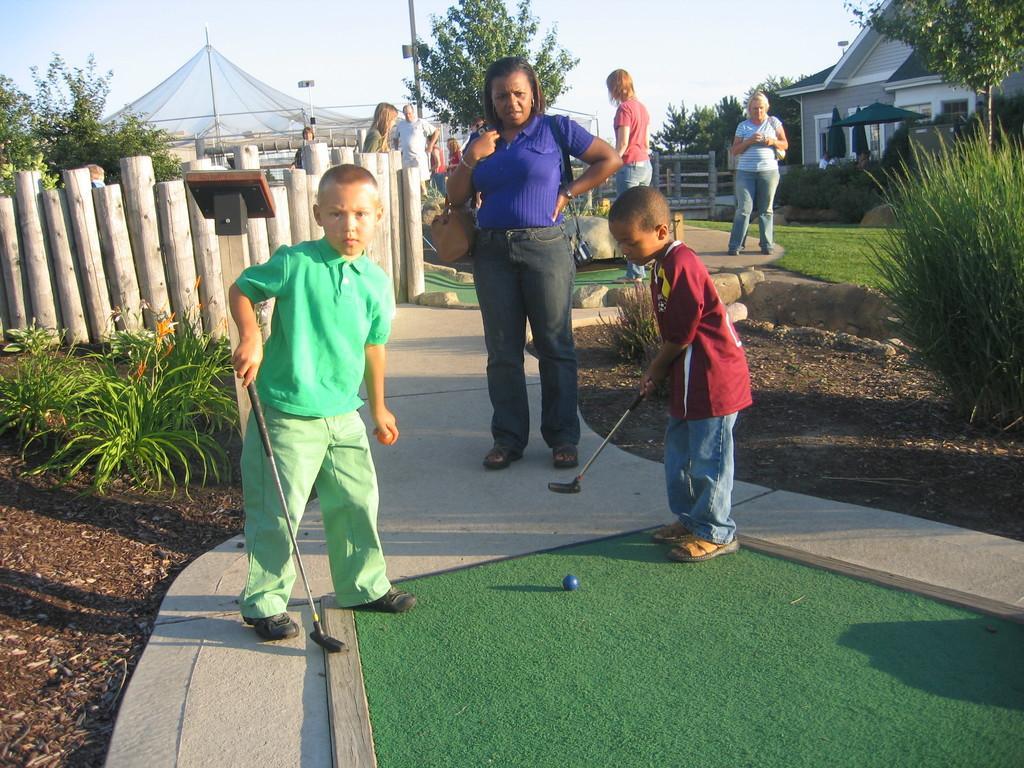Describe this image in one or two sentences. In this image, we can see few people. Two kids are playing a game and holding sticks. Here a boy is holding a ball. At the bottom, we can see green color object, walkway, ball and ground. Background we can see few plants, grass wooden objects, trees, house, poles, net and sky. 